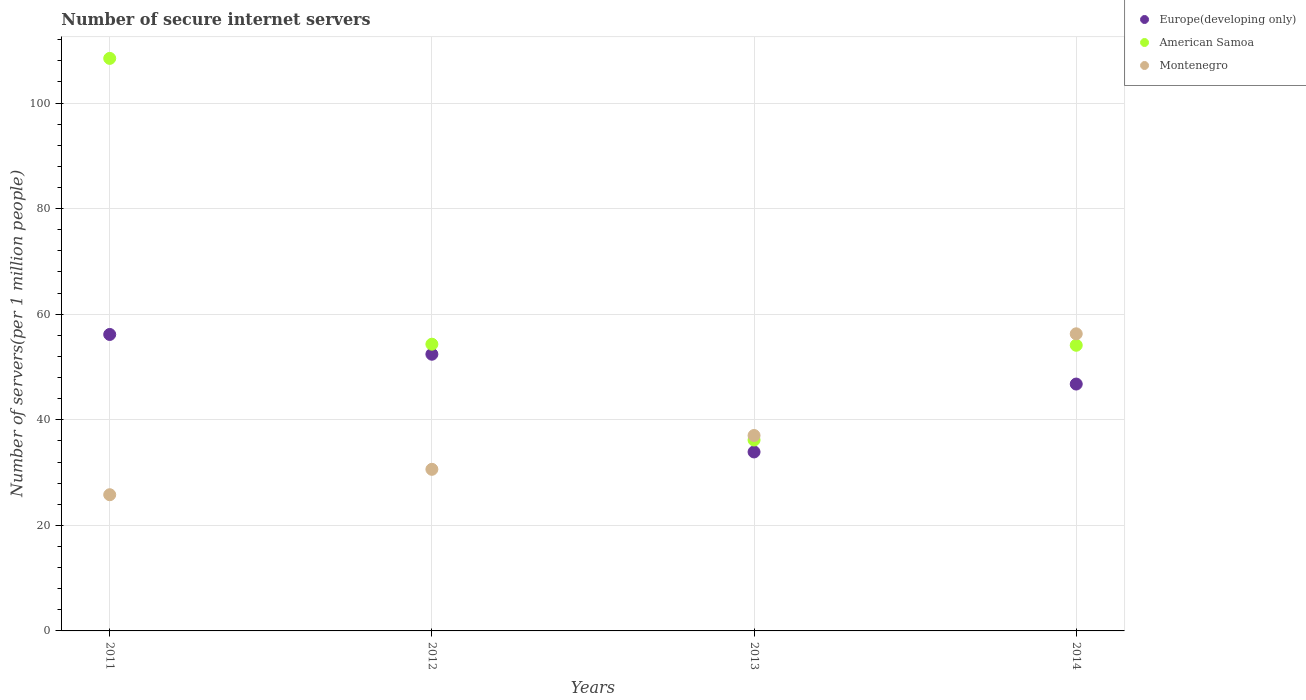Is the number of dotlines equal to the number of legend labels?
Make the answer very short. Yes. What is the number of secure internet servers in Europe(developing only) in 2011?
Your answer should be very brief. 56.17. Across all years, what is the maximum number of secure internet servers in Montenegro?
Provide a short and direct response. 56.29. Across all years, what is the minimum number of secure internet servers in American Samoa?
Keep it short and to the point. 36.17. In which year was the number of secure internet servers in American Samoa minimum?
Your response must be concise. 2013. What is the total number of secure internet servers in Montenegro in the graph?
Offer a terse response. 149.73. What is the difference between the number of secure internet servers in American Samoa in 2013 and that in 2014?
Give a very brief answer. -17.95. What is the difference between the number of secure internet servers in Montenegro in 2011 and the number of secure internet servers in Europe(developing only) in 2014?
Give a very brief answer. -20.97. What is the average number of secure internet servers in American Samoa per year?
Provide a succinct answer. 63.27. In the year 2014, what is the difference between the number of secure internet servers in American Samoa and number of secure internet servers in Montenegro?
Your answer should be compact. -2.17. In how many years, is the number of secure internet servers in Montenegro greater than 100?
Your answer should be compact. 0. What is the ratio of the number of secure internet servers in Europe(developing only) in 2013 to that in 2014?
Provide a short and direct response. 0.72. Is the number of secure internet servers in American Samoa in 2012 less than that in 2013?
Give a very brief answer. No. Is the difference between the number of secure internet servers in American Samoa in 2011 and 2013 greater than the difference between the number of secure internet servers in Montenegro in 2011 and 2013?
Your answer should be very brief. Yes. What is the difference between the highest and the second highest number of secure internet servers in Montenegro?
Your answer should be compact. 19.26. What is the difference between the highest and the lowest number of secure internet servers in Montenegro?
Ensure brevity in your answer.  30.49. Is the sum of the number of secure internet servers in American Samoa in 2011 and 2013 greater than the maximum number of secure internet servers in Europe(developing only) across all years?
Your answer should be compact. Yes. Is it the case that in every year, the sum of the number of secure internet servers in American Samoa and number of secure internet servers in Montenegro  is greater than the number of secure internet servers in Europe(developing only)?
Your answer should be compact. Yes. Does the number of secure internet servers in Europe(developing only) monotonically increase over the years?
Offer a very short reply. No. Is the number of secure internet servers in American Samoa strictly greater than the number of secure internet servers in Europe(developing only) over the years?
Ensure brevity in your answer.  Yes. Is the number of secure internet servers in Montenegro strictly less than the number of secure internet servers in American Samoa over the years?
Offer a terse response. No. How many dotlines are there?
Make the answer very short. 3. Does the graph contain any zero values?
Provide a succinct answer. No. Where does the legend appear in the graph?
Your answer should be very brief. Top right. What is the title of the graph?
Your answer should be compact. Number of secure internet servers. What is the label or title of the Y-axis?
Keep it short and to the point. Number of servers(per 1 million people). What is the Number of servers(per 1 million people) in Europe(developing only) in 2011?
Offer a very short reply. 56.17. What is the Number of servers(per 1 million people) of American Samoa in 2011?
Your response must be concise. 108.47. What is the Number of servers(per 1 million people) of Montenegro in 2011?
Your response must be concise. 25.8. What is the Number of servers(per 1 million people) in Europe(developing only) in 2012?
Give a very brief answer. 52.42. What is the Number of servers(per 1 million people) of American Samoa in 2012?
Provide a short and direct response. 54.32. What is the Number of servers(per 1 million people) of Montenegro in 2012?
Offer a terse response. 30.62. What is the Number of servers(per 1 million people) of Europe(developing only) in 2013?
Give a very brief answer. 33.91. What is the Number of servers(per 1 million people) of American Samoa in 2013?
Give a very brief answer. 36.17. What is the Number of servers(per 1 million people) of Montenegro in 2013?
Provide a short and direct response. 37.02. What is the Number of servers(per 1 million people) of Europe(developing only) in 2014?
Your answer should be compact. 46.77. What is the Number of servers(per 1 million people) in American Samoa in 2014?
Provide a short and direct response. 54.12. What is the Number of servers(per 1 million people) in Montenegro in 2014?
Make the answer very short. 56.29. Across all years, what is the maximum Number of servers(per 1 million people) of Europe(developing only)?
Make the answer very short. 56.17. Across all years, what is the maximum Number of servers(per 1 million people) of American Samoa?
Provide a short and direct response. 108.47. Across all years, what is the maximum Number of servers(per 1 million people) in Montenegro?
Offer a very short reply. 56.29. Across all years, what is the minimum Number of servers(per 1 million people) of Europe(developing only)?
Your answer should be compact. 33.91. Across all years, what is the minimum Number of servers(per 1 million people) of American Samoa?
Offer a very short reply. 36.17. Across all years, what is the minimum Number of servers(per 1 million people) in Montenegro?
Your answer should be compact. 25.8. What is the total Number of servers(per 1 million people) in Europe(developing only) in the graph?
Provide a short and direct response. 189.26. What is the total Number of servers(per 1 million people) in American Samoa in the graph?
Ensure brevity in your answer.  253.07. What is the total Number of servers(per 1 million people) in Montenegro in the graph?
Make the answer very short. 149.73. What is the difference between the Number of servers(per 1 million people) in Europe(developing only) in 2011 and that in 2012?
Ensure brevity in your answer.  3.75. What is the difference between the Number of servers(per 1 million people) of American Samoa in 2011 and that in 2012?
Make the answer very short. 54.15. What is the difference between the Number of servers(per 1 million people) of Montenegro in 2011 and that in 2012?
Make the answer very short. -4.81. What is the difference between the Number of servers(per 1 million people) in Europe(developing only) in 2011 and that in 2013?
Your response must be concise. 22.26. What is the difference between the Number of servers(per 1 million people) of American Samoa in 2011 and that in 2013?
Your response must be concise. 72.3. What is the difference between the Number of servers(per 1 million people) in Montenegro in 2011 and that in 2013?
Provide a succinct answer. -11.22. What is the difference between the Number of servers(per 1 million people) of Europe(developing only) in 2011 and that in 2014?
Keep it short and to the point. 9.4. What is the difference between the Number of servers(per 1 million people) of American Samoa in 2011 and that in 2014?
Your answer should be very brief. 54.35. What is the difference between the Number of servers(per 1 million people) in Montenegro in 2011 and that in 2014?
Your answer should be very brief. -30.48. What is the difference between the Number of servers(per 1 million people) in Europe(developing only) in 2012 and that in 2013?
Your answer should be compact. 18.51. What is the difference between the Number of servers(per 1 million people) of American Samoa in 2012 and that in 2013?
Provide a succinct answer. 18.16. What is the difference between the Number of servers(per 1 million people) of Montenegro in 2012 and that in 2013?
Your answer should be compact. -6.41. What is the difference between the Number of servers(per 1 million people) in Europe(developing only) in 2012 and that in 2014?
Provide a succinct answer. 5.65. What is the difference between the Number of servers(per 1 million people) of American Samoa in 2012 and that in 2014?
Provide a succinct answer. 0.2. What is the difference between the Number of servers(per 1 million people) of Montenegro in 2012 and that in 2014?
Keep it short and to the point. -25.67. What is the difference between the Number of servers(per 1 million people) in Europe(developing only) in 2013 and that in 2014?
Your response must be concise. -12.86. What is the difference between the Number of servers(per 1 million people) of American Samoa in 2013 and that in 2014?
Keep it short and to the point. -17.95. What is the difference between the Number of servers(per 1 million people) of Montenegro in 2013 and that in 2014?
Offer a very short reply. -19.26. What is the difference between the Number of servers(per 1 million people) of Europe(developing only) in 2011 and the Number of servers(per 1 million people) of American Samoa in 2012?
Your answer should be very brief. 1.84. What is the difference between the Number of servers(per 1 million people) of Europe(developing only) in 2011 and the Number of servers(per 1 million people) of Montenegro in 2012?
Your answer should be compact. 25.55. What is the difference between the Number of servers(per 1 million people) in American Samoa in 2011 and the Number of servers(per 1 million people) in Montenegro in 2012?
Your answer should be compact. 77.85. What is the difference between the Number of servers(per 1 million people) in Europe(developing only) in 2011 and the Number of servers(per 1 million people) in American Samoa in 2013?
Your response must be concise. 20. What is the difference between the Number of servers(per 1 million people) of Europe(developing only) in 2011 and the Number of servers(per 1 million people) of Montenegro in 2013?
Ensure brevity in your answer.  19.14. What is the difference between the Number of servers(per 1 million people) of American Samoa in 2011 and the Number of servers(per 1 million people) of Montenegro in 2013?
Provide a short and direct response. 71.44. What is the difference between the Number of servers(per 1 million people) of Europe(developing only) in 2011 and the Number of servers(per 1 million people) of American Samoa in 2014?
Ensure brevity in your answer.  2.05. What is the difference between the Number of servers(per 1 million people) of Europe(developing only) in 2011 and the Number of servers(per 1 million people) of Montenegro in 2014?
Your answer should be very brief. -0.12. What is the difference between the Number of servers(per 1 million people) of American Samoa in 2011 and the Number of servers(per 1 million people) of Montenegro in 2014?
Give a very brief answer. 52.18. What is the difference between the Number of servers(per 1 million people) in Europe(developing only) in 2012 and the Number of servers(per 1 million people) in American Samoa in 2013?
Offer a very short reply. 16.25. What is the difference between the Number of servers(per 1 million people) in Europe(developing only) in 2012 and the Number of servers(per 1 million people) in Montenegro in 2013?
Your response must be concise. 15.39. What is the difference between the Number of servers(per 1 million people) of American Samoa in 2012 and the Number of servers(per 1 million people) of Montenegro in 2013?
Ensure brevity in your answer.  17.3. What is the difference between the Number of servers(per 1 million people) of Europe(developing only) in 2012 and the Number of servers(per 1 million people) of American Samoa in 2014?
Your answer should be compact. -1.7. What is the difference between the Number of servers(per 1 million people) in Europe(developing only) in 2012 and the Number of servers(per 1 million people) in Montenegro in 2014?
Ensure brevity in your answer.  -3.87. What is the difference between the Number of servers(per 1 million people) in American Samoa in 2012 and the Number of servers(per 1 million people) in Montenegro in 2014?
Your response must be concise. -1.97. What is the difference between the Number of servers(per 1 million people) of Europe(developing only) in 2013 and the Number of servers(per 1 million people) of American Samoa in 2014?
Offer a very short reply. -20.21. What is the difference between the Number of servers(per 1 million people) in Europe(developing only) in 2013 and the Number of servers(per 1 million people) in Montenegro in 2014?
Your answer should be very brief. -22.38. What is the difference between the Number of servers(per 1 million people) in American Samoa in 2013 and the Number of servers(per 1 million people) in Montenegro in 2014?
Give a very brief answer. -20.12. What is the average Number of servers(per 1 million people) in Europe(developing only) per year?
Give a very brief answer. 47.32. What is the average Number of servers(per 1 million people) of American Samoa per year?
Provide a short and direct response. 63.27. What is the average Number of servers(per 1 million people) of Montenegro per year?
Your answer should be compact. 37.43. In the year 2011, what is the difference between the Number of servers(per 1 million people) in Europe(developing only) and Number of servers(per 1 million people) in American Samoa?
Your answer should be compact. -52.3. In the year 2011, what is the difference between the Number of servers(per 1 million people) of Europe(developing only) and Number of servers(per 1 million people) of Montenegro?
Keep it short and to the point. 30.36. In the year 2011, what is the difference between the Number of servers(per 1 million people) of American Samoa and Number of servers(per 1 million people) of Montenegro?
Offer a terse response. 82.66. In the year 2012, what is the difference between the Number of servers(per 1 million people) of Europe(developing only) and Number of servers(per 1 million people) of American Samoa?
Offer a terse response. -1.9. In the year 2012, what is the difference between the Number of servers(per 1 million people) of Europe(developing only) and Number of servers(per 1 million people) of Montenegro?
Give a very brief answer. 21.8. In the year 2012, what is the difference between the Number of servers(per 1 million people) in American Samoa and Number of servers(per 1 million people) in Montenegro?
Your response must be concise. 23.71. In the year 2013, what is the difference between the Number of servers(per 1 million people) of Europe(developing only) and Number of servers(per 1 million people) of American Samoa?
Offer a terse response. -2.26. In the year 2013, what is the difference between the Number of servers(per 1 million people) of Europe(developing only) and Number of servers(per 1 million people) of Montenegro?
Offer a terse response. -3.12. In the year 2013, what is the difference between the Number of servers(per 1 million people) in American Samoa and Number of servers(per 1 million people) in Montenegro?
Offer a terse response. -0.86. In the year 2014, what is the difference between the Number of servers(per 1 million people) of Europe(developing only) and Number of servers(per 1 million people) of American Samoa?
Your answer should be compact. -7.35. In the year 2014, what is the difference between the Number of servers(per 1 million people) of Europe(developing only) and Number of servers(per 1 million people) of Montenegro?
Offer a very short reply. -9.52. In the year 2014, what is the difference between the Number of servers(per 1 million people) in American Samoa and Number of servers(per 1 million people) in Montenegro?
Offer a very short reply. -2.17. What is the ratio of the Number of servers(per 1 million people) of Europe(developing only) in 2011 to that in 2012?
Make the answer very short. 1.07. What is the ratio of the Number of servers(per 1 million people) in American Samoa in 2011 to that in 2012?
Ensure brevity in your answer.  2. What is the ratio of the Number of servers(per 1 million people) of Montenegro in 2011 to that in 2012?
Offer a very short reply. 0.84. What is the ratio of the Number of servers(per 1 million people) in Europe(developing only) in 2011 to that in 2013?
Make the answer very short. 1.66. What is the ratio of the Number of servers(per 1 million people) of American Samoa in 2011 to that in 2013?
Your answer should be compact. 3. What is the ratio of the Number of servers(per 1 million people) in Montenegro in 2011 to that in 2013?
Provide a short and direct response. 0.7. What is the ratio of the Number of servers(per 1 million people) of Europe(developing only) in 2011 to that in 2014?
Make the answer very short. 1.2. What is the ratio of the Number of servers(per 1 million people) in American Samoa in 2011 to that in 2014?
Give a very brief answer. 2. What is the ratio of the Number of servers(per 1 million people) of Montenegro in 2011 to that in 2014?
Provide a short and direct response. 0.46. What is the ratio of the Number of servers(per 1 million people) of Europe(developing only) in 2012 to that in 2013?
Make the answer very short. 1.55. What is the ratio of the Number of servers(per 1 million people) of American Samoa in 2012 to that in 2013?
Make the answer very short. 1.5. What is the ratio of the Number of servers(per 1 million people) in Montenegro in 2012 to that in 2013?
Keep it short and to the point. 0.83. What is the ratio of the Number of servers(per 1 million people) of Europe(developing only) in 2012 to that in 2014?
Your answer should be very brief. 1.12. What is the ratio of the Number of servers(per 1 million people) of Montenegro in 2012 to that in 2014?
Your answer should be very brief. 0.54. What is the ratio of the Number of servers(per 1 million people) of Europe(developing only) in 2013 to that in 2014?
Provide a succinct answer. 0.72. What is the ratio of the Number of servers(per 1 million people) of American Samoa in 2013 to that in 2014?
Offer a very short reply. 0.67. What is the ratio of the Number of servers(per 1 million people) of Montenegro in 2013 to that in 2014?
Ensure brevity in your answer.  0.66. What is the difference between the highest and the second highest Number of servers(per 1 million people) in Europe(developing only)?
Your answer should be very brief. 3.75. What is the difference between the highest and the second highest Number of servers(per 1 million people) of American Samoa?
Your answer should be compact. 54.15. What is the difference between the highest and the second highest Number of servers(per 1 million people) of Montenegro?
Offer a terse response. 19.26. What is the difference between the highest and the lowest Number of servers(per 1 million people) of Europe(developing only)?
Your answer should be compact. 22.26. What is the difference between the highest and the lowest Number of servers(per 1 million people) of American Samoa?
Your answer should be compact. 72.3. What is the difference between the highest and the lowest Number of servers(per 1 million people) of Montenegro?
Your answer should be compact. 30.48. 